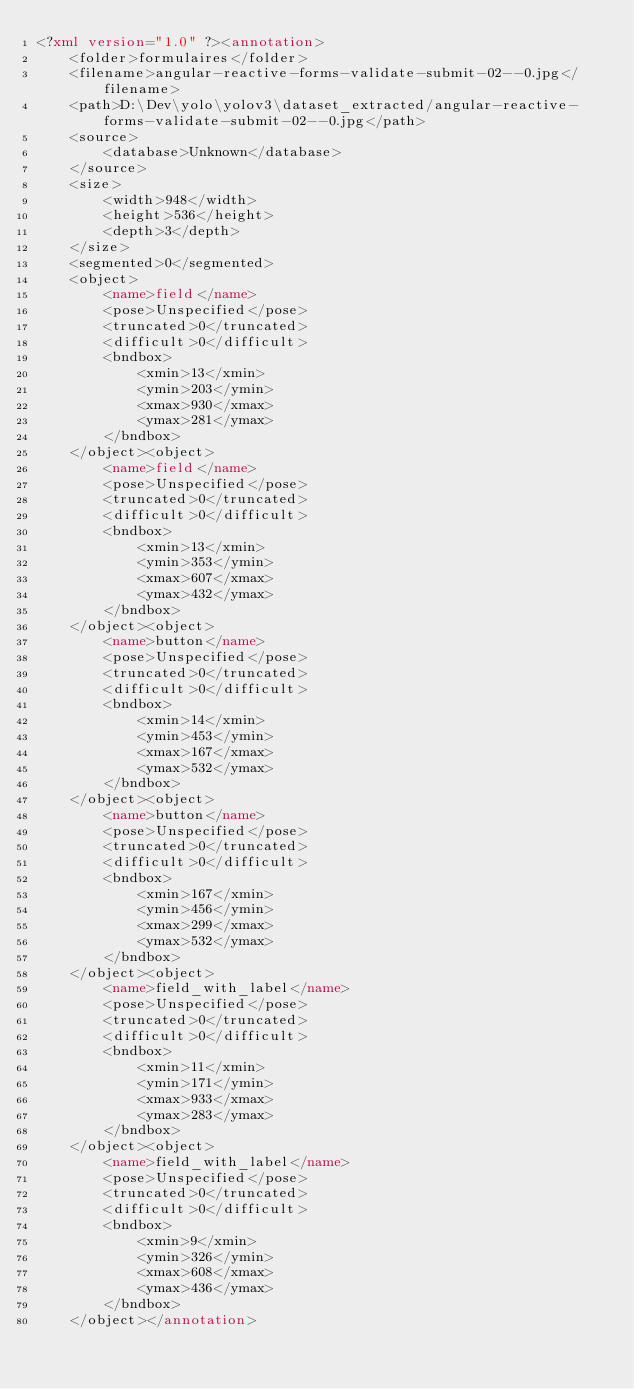<code> <loc_0><loc_0><loc_500><loc_500><_XML_><?xml version="1.0" ?><annotation>
    <folder>formulaires</folder>
    <filename>angular-reactive-forms-validate-submit-02--0.jpg</filename>
    <path>D:\Dev\yolo\yolov3\dataset_extracted/angular-reactive-forms-validate-submit-02--0.jpg</path>
    <source>
        <database>Unknown</database>
    </source>
    <size>
        <width>948</width>
        <height>536</height>
        <depth>3</depth>
    </size>
    <segmented>0</segmented>
    <object>
        <name>field</name>
        <pose>Unspecified</pose>
        <truncated>0</truncated>
        <difficult>0</difficult>
        <bndbox>
            <xmin>13</xmin>
            <ymin>203</ymin>
            <xmax>930</xmax>
            <ymax>281</ymax>
        </bndbox>
    </object><object>
        <name>field</name>
        <pose>Unspecified</pose>
        <truncated>0</truncated>
        <difficult>0</difficult>
        <bndbox>
            <xmin>13</xmin>
            <ymin>353</ymin>
            <xmax>607</xmax>
            <ymax>432</ymax>
        </bndbox>
    </object><object>
        <name>button</name>
        <pose>Unspecified</pose>
        <truncated>0</truncated>
        <difficult>0</difficult>
        <bndbox>
            <xmin>14</xmin>
            <ymin>453</ymin>
            <xmax>167</xmax>
            <ymax>532</ymax>
        </bndbox>
    </object><object>
        <name>button</name>
        <pose>Unspecified</pose>
        <truncated>0</truncated>
        <difficult>0</difficult>
        <bndbox>
            <xmin>167</xmin>
            <ymin>456</ymin>
            <xmax>299</xmax>
            <ymax>532</ymax>
        </bndbox>
    </object><object>
        <name>field_with_label</name>
        <pose>Unspecified</pose>
        <truncated>0</truncated>
        <difficult>0</difficult>
        <bndbox>
            <xmin>11</xmin>
            <ymin>171</ymin>
            <xmax>933</xmax>
            <ymax>283</ymax>
        </bndbox>
    </object><object>
        <name>field_with_label</name>
        <pose>Unspecified</pose>
        <truncated>0</truncated>
        <difficult>0</difficult>
        <bndbox>
            <xmin>9</xmin>
            <ymin>326</ymin>
            <xmax>608</xmax>
            <ymax>436</ymax>
        </bndbox>
    </object></annotation></code> 